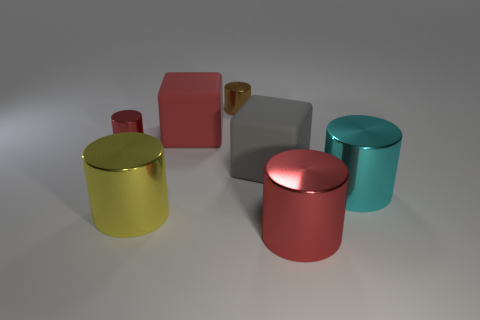Subtract all cyan cylinders. How many cylinders are left? 4 Subtract all blue balls. How many red cylinders are left? 2 Add 1 red rubber blocks. How many objects exist? 8 Subtract all cyan cylinders. How many cylinders are left? 4 Subtract all cylinders. How many objects are left? 2 Subtract 3 cylinders. How many cylinders are left? 2 Subtract all cyan cubes. Subtract all blue spheres. How many cubes are left? 2 Add 7 red metal cylinders. How many red metal cylinders exist? 9 Subtract 0 purple cylinders. How many objects are left? 7 Subtract all big red objects. Subtract all cyan shiny cylinders. How many objects are left? 4 